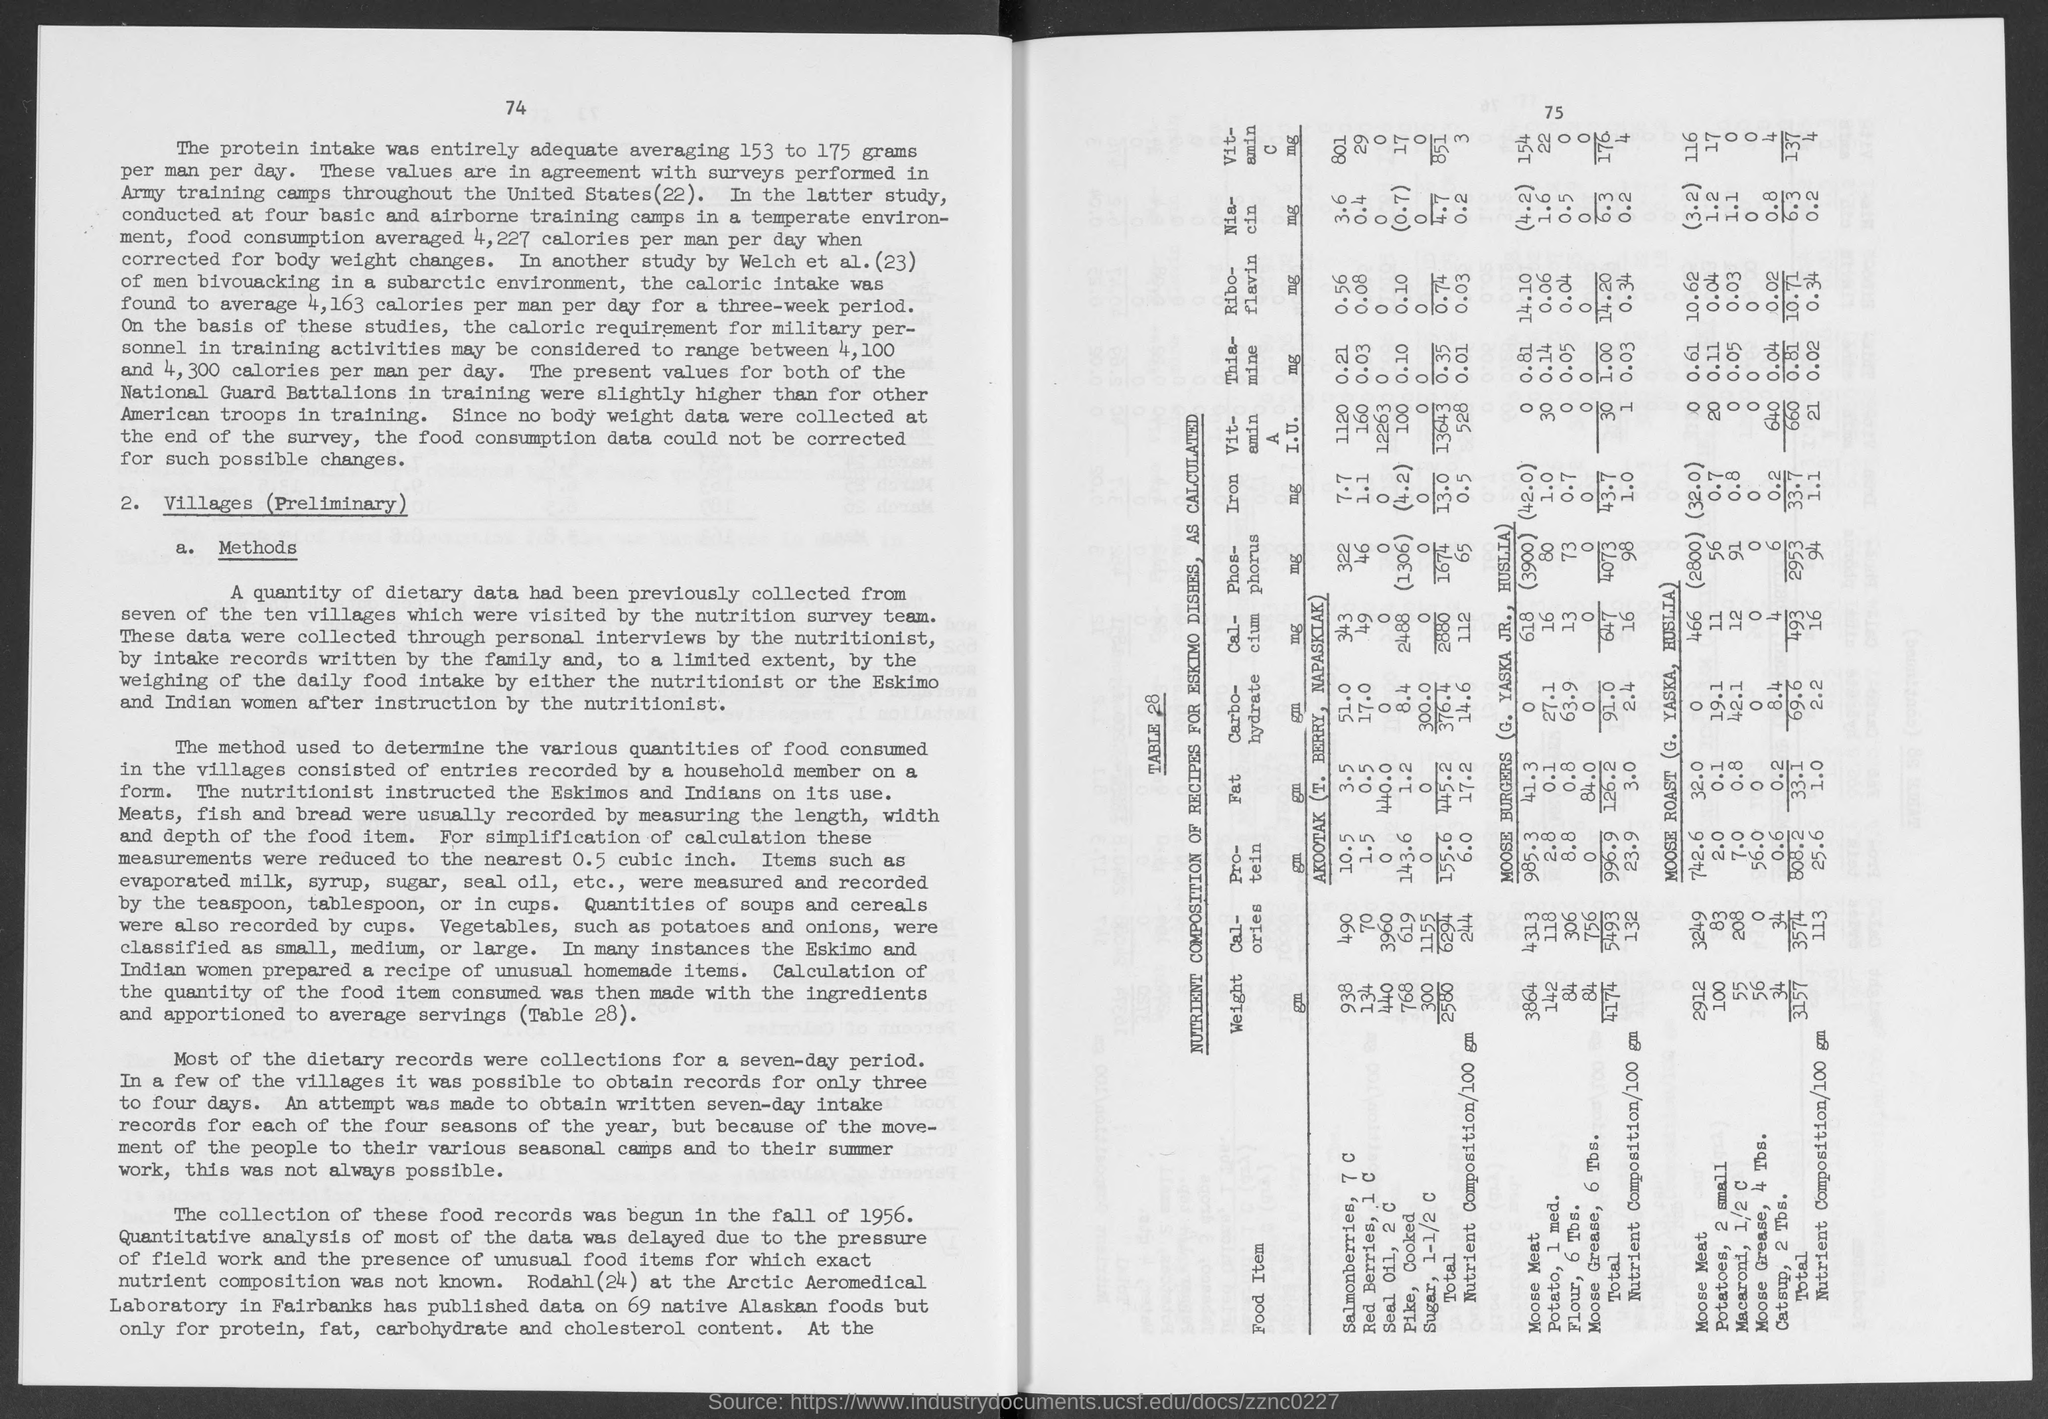What is the number at top-right corner of the page?
Your answer should be compact. 75. 